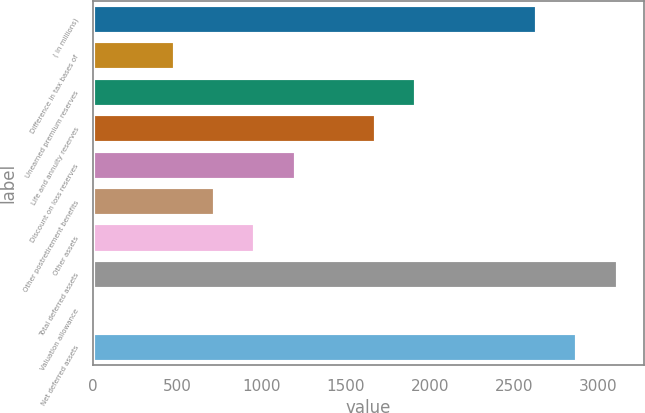Convert chart to OTSL. <chart><loc_0><loc_0><loc_500><loc_500><bar_chart><fcel>( in millions)<fcel>Difference in tax bases of<fcel>Unearned premium reserves<fcel>Life and annuity reserves<fcel>Discount on loss reserves<fcel>Other postretirement benefits<fcel>Other assets<fcel>Total deferred assets<fcel>Valuation allowance<fcel>Net deferred assets<nl><fcel>2638.3<fcel>484.6<fcel>1920.4<fcel>1681.1<fcel>1202.5<fcel>723.9<fcel>963.2<fcel>3116.9<fcel>6<fcel>2877.6<nl></chart> 